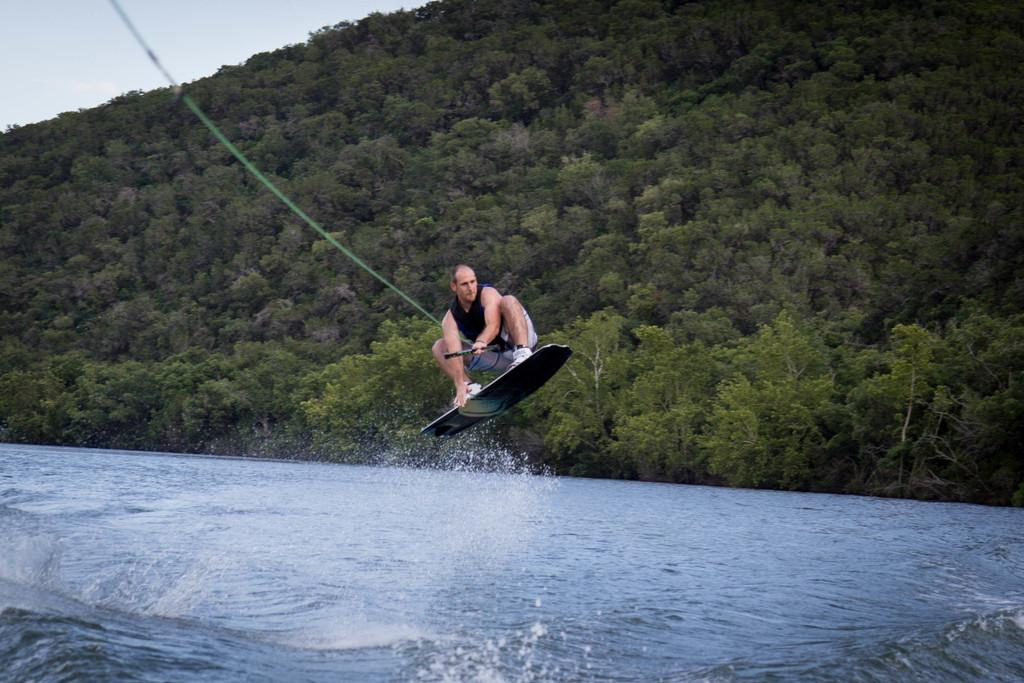What activity is the person in the image engaged in? The person is on a surfing board in the image. What is the person holding while surfing? The person is holding a rope. What can be seen in the background of the image? There are trees in the background of the image. What is visible at the bottom of the image? Water is visible at the bottom of the image. Can you see a snail moving across the surfing board in the image? There is no snail present on the surfing board in the image. 